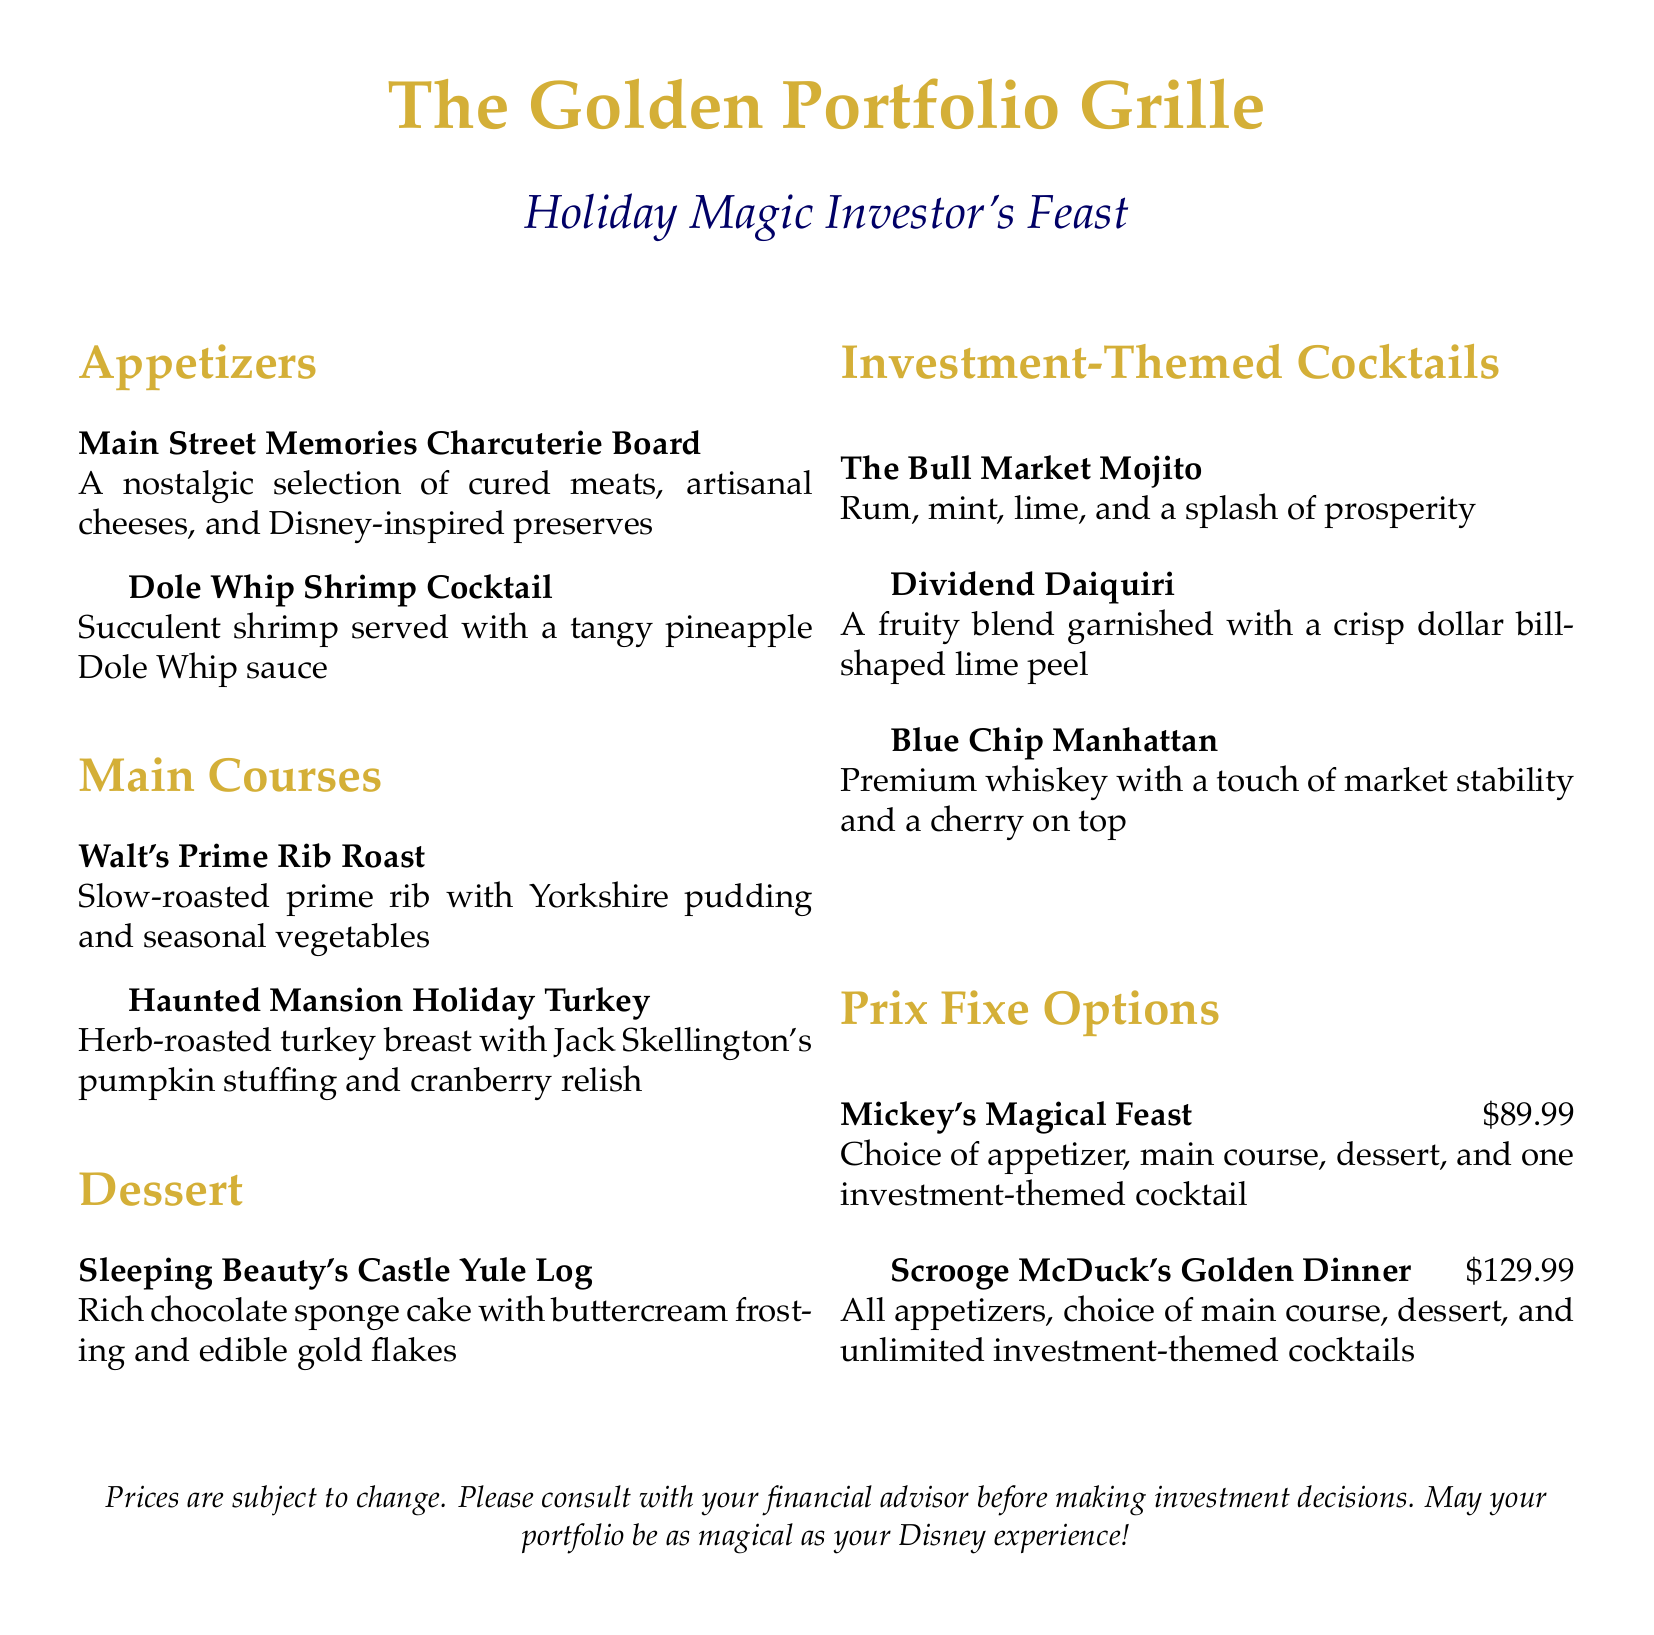What is the name of the restaurant? The name of the restaurant is prominently displayed at the top of the document.
Answer: The Golden Portfolio Grille What is the price of Scrooge McDuck's Golden Dinner? The price is clearly listed alongside the dinner option in the Prix Fixe Options section.
Answer: 129.99 What type of soup is on the menu? The document does not include any soup options, so there is no mention of a type.
Answer: None How many investment-themed cocktails are listed? The number of drinks can be counted in the Investment-Themed Cocktails section of the document.
Answer: Three What is the main ingredient in The Bull Market Mojito? The primary component is specified in the description of the cocktail.
Answer: Rum What is included in Mickey's Magical Feast? The details of what is included can be found in the description of the prix fixe options.
Answer: Choice of appetizer, main course, dessert, and one investment-themed cocktail Which main course features Jack Skellington? The main courses provide insight into their themes, particularly notable characters from Disney.
Answer: Haunted Mansion Holiday Turkey What dessert is named after a Disney princess? The dessert options include a title associated with a well-known character.
Answer: Sleeping Beauty's Castle Yule Log What cocktail garnished with a dollar bill-shaped lime peel? The description mentions the specific garnish alongside the cocktail name.
Answer: Dividend Daiquiri 